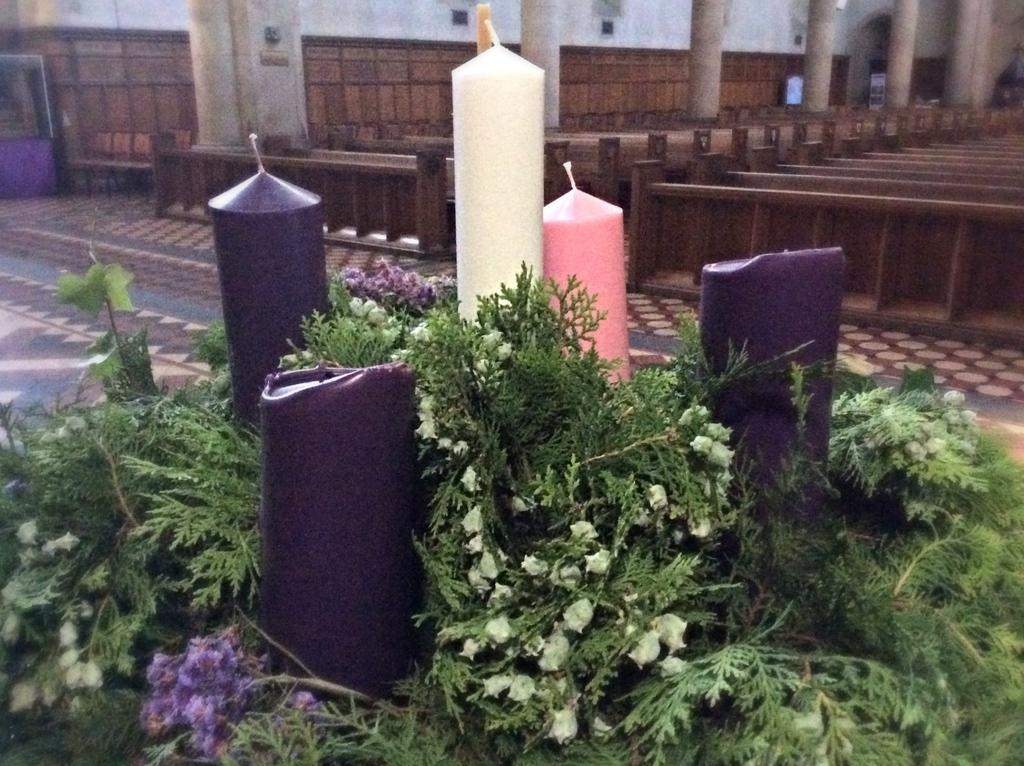What type of location is depicted in the image? The image shows an inside view of a church. What can be seen at the front of the image? There are big candles in the front of the image. Are there any plants visible in the image? Yes, there are green plants in the image. What type of seating is available in the church? There are wooden benches visible in the image. How many bikes are parked near the wooden benches in the image? There are no bikes present in the image; it shows an inside view of a church with wooden benches and other church-related elements. 